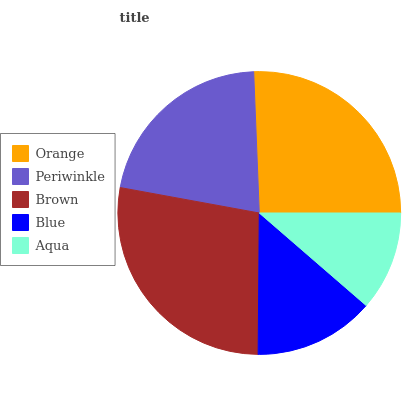Is Aqua the minimum?
Answer yes or no. Yes. Is Brown the maximum?
Answer yes or no. Yes. Is Periwinkle the minimum?
Answer yes or no. No. Is Periwinkle the maximum?
Answer yes or no. No. Is Orange greater than Periwinkle?
Answer yes or no. Yes. Is Periwinkle less than Orange?
Answer yes or no. Yes. Is Periwinkle greater than Orange?
Answer yes or no. No. Is Orange less than Periwinkle?
Answer yes or no. No. Is Periwinkle the high median?
Answer yes or no. Yes. Is Periwinkle the low median?
Answer yes or no. Yes. Is Aqua the high median?
Answer yes or no. No. Is Brown the low median?
Answer yes or no. No. 